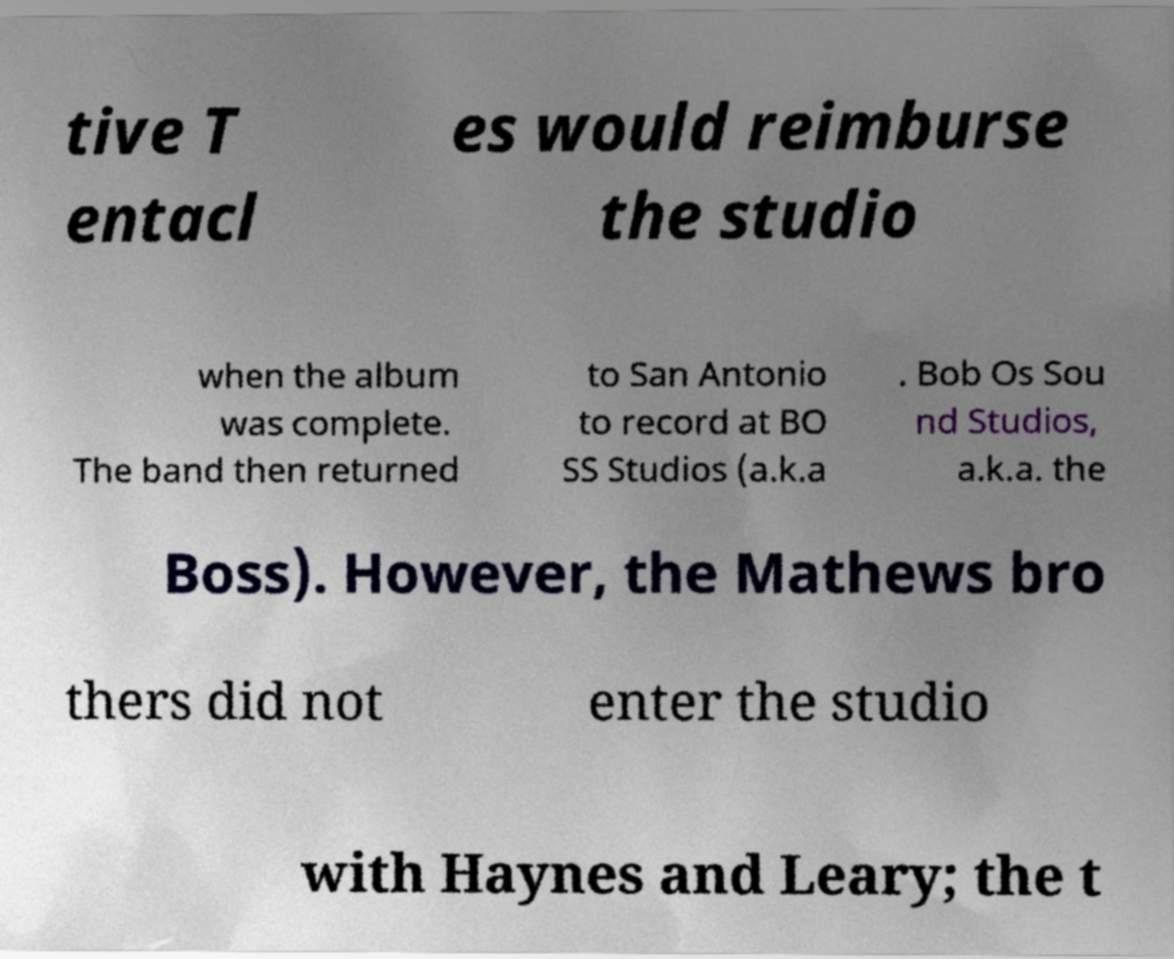I need the written content from this picture converted into text. Can you do that? tive T entacl es would reimburse the studio when the album was complete. The band then returned to San Antonio to record at BO SS Studios (a.k.a . Bob Os Sou nd Studios, a.k.a. the Boss). However, the Mathews bro thers did not enter the studio with Haynes and Leary; the t 